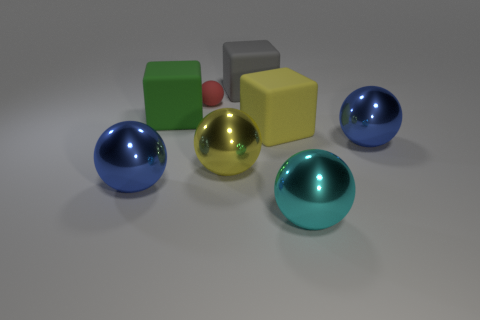Subtract all tiny red rubber balls. How many balls are left? 4 Add 1 large yellow blocks. How many objects exist? 9 Subtract all green blocks. How many blocks are left? 2 Subtract 2 cubes. How many cubes are left? 1 Subtract all blocks. How many objects are left? 5 Subtract all big cyan spheres. Subtract all large green objects. How many objects are left? 6 Add 6 large yellow rubber objects. How many large yellow rubber objects are left? 7 Add 6 large yellow things. How many large yellow things exist? 8 Subtract 0 red cylinders. How many objects are left? 8 Subtract all yellow spheres. Subtract all green cylinders. How many spheres are left? 4 